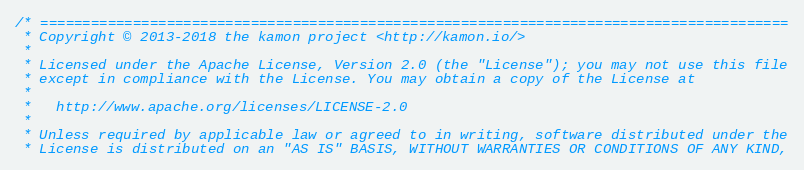Convert code to text. <code><loc_0><loc_0><loc_500><loc_500><_Scala_>/* =========================================================================================
 * Copyright © 2013-2018 the kamon project <http://kamon.io/>
 *
 * Licensed under the Apache License, Version 2.0 (the "License"); you may not use this file
 * except in compliance with the License. You may obtain a copy of the License at
 *
 *   http://www.apache.org/licenses/LICENSE-2.0
 *
 * Unless required by applicable law or agreed to in writing, software distributed under the
 * License is distributed on an "AS IS" BASIS, WITHOUT WARRANTIES OR CONDITIONS OF ANY KIND,</code> 